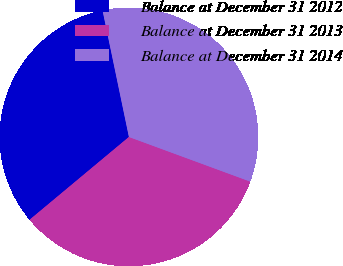Convert chart. <chart><loc_0><loc_0><loc_500><loc_500><pie_chart><fcel>Balance at December 31 2012<fcel>Balance at December 31 2013<fcel>Balance at December 31 2014<nl><fcel>32.79%<fcel>33.33%<fcel>33.88%<nl></chart> 